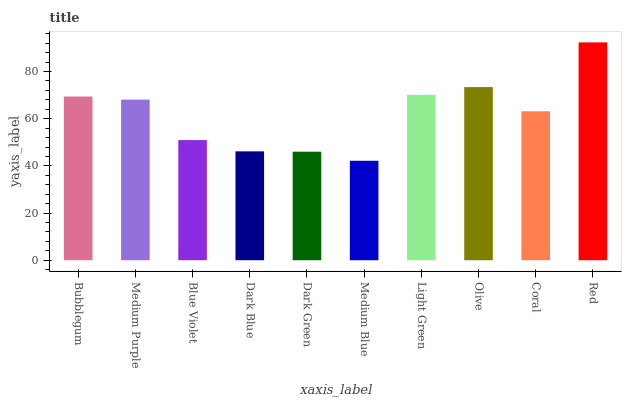Is Medium Blue the minimum?
Answer yes or no. Yes. Is Red the maximum?
Answer yes or no. Yes. Is Medium Purple the minimum?
Answer yes or no. No. Is Medium Purple the maximum?
Answer yes or no. No. Is Bubblegum greater than Medium Purple?
Answer yes or no. Yes. Is Medium Purple less than Bubblegum?
Answer yes or no. Yes. Is Medium Purple greater than Bubblegum?
Answer yes or no. No. Is Bubblegum less than Medium Purple?
Answer yes or no. No. Is Medium Purple the high median?
Answer yes or no. Yes. Is Coral the low median?
Answer yes or no. Yes. Is Blue Violet the high median?
Answer yes or no. No. Is Medium Blue the low median?
Answer yes or no. No. 